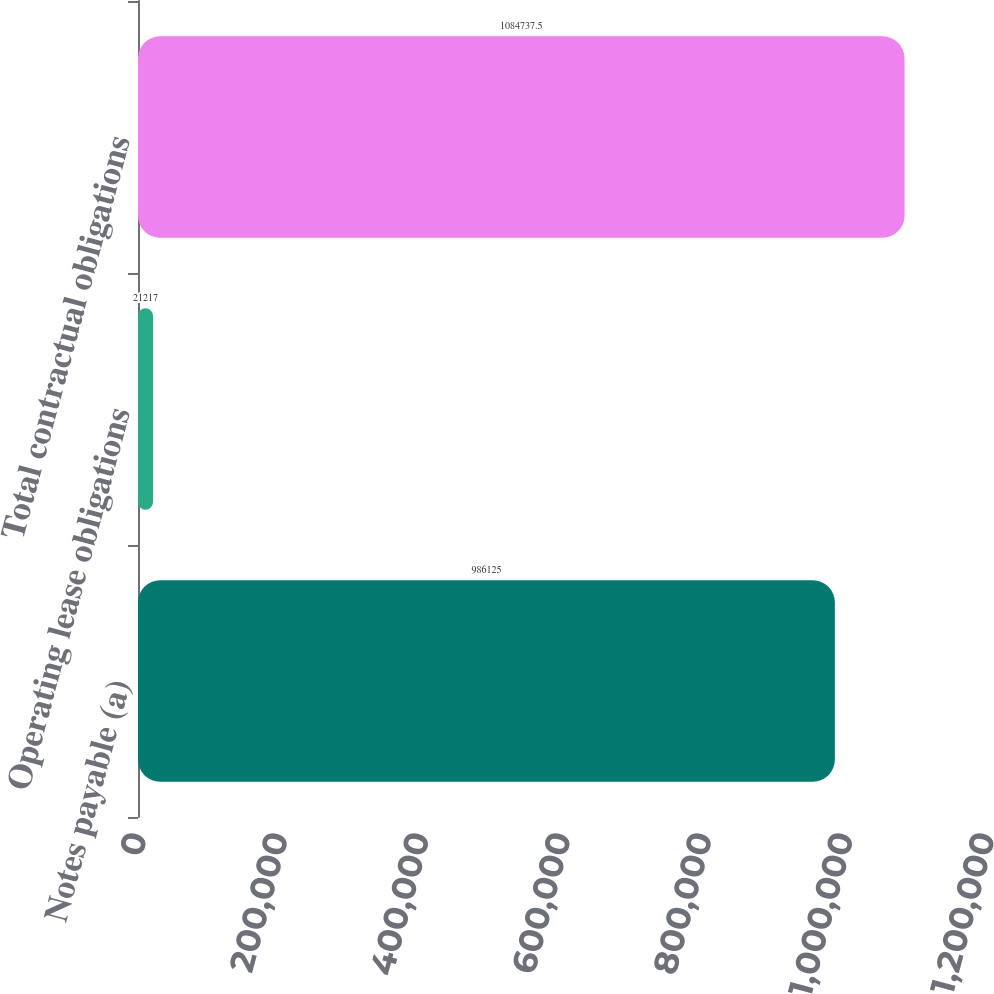Convert chart to OTSL. <chart><loc_0><loc_0><loc_500><loc_500><bar_chart><fcel>Notes payable (a)<fcel>Operating lease obligations<fcel>Total contractual obligations<nl><fcel>986125<fcel>21217<fcel>1.08474e+06<nl></chart> 